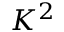Convert formula to latex. <formula><loc_0><loc_0><loc_500><loc_500>K ^ { 2 }</formula> 